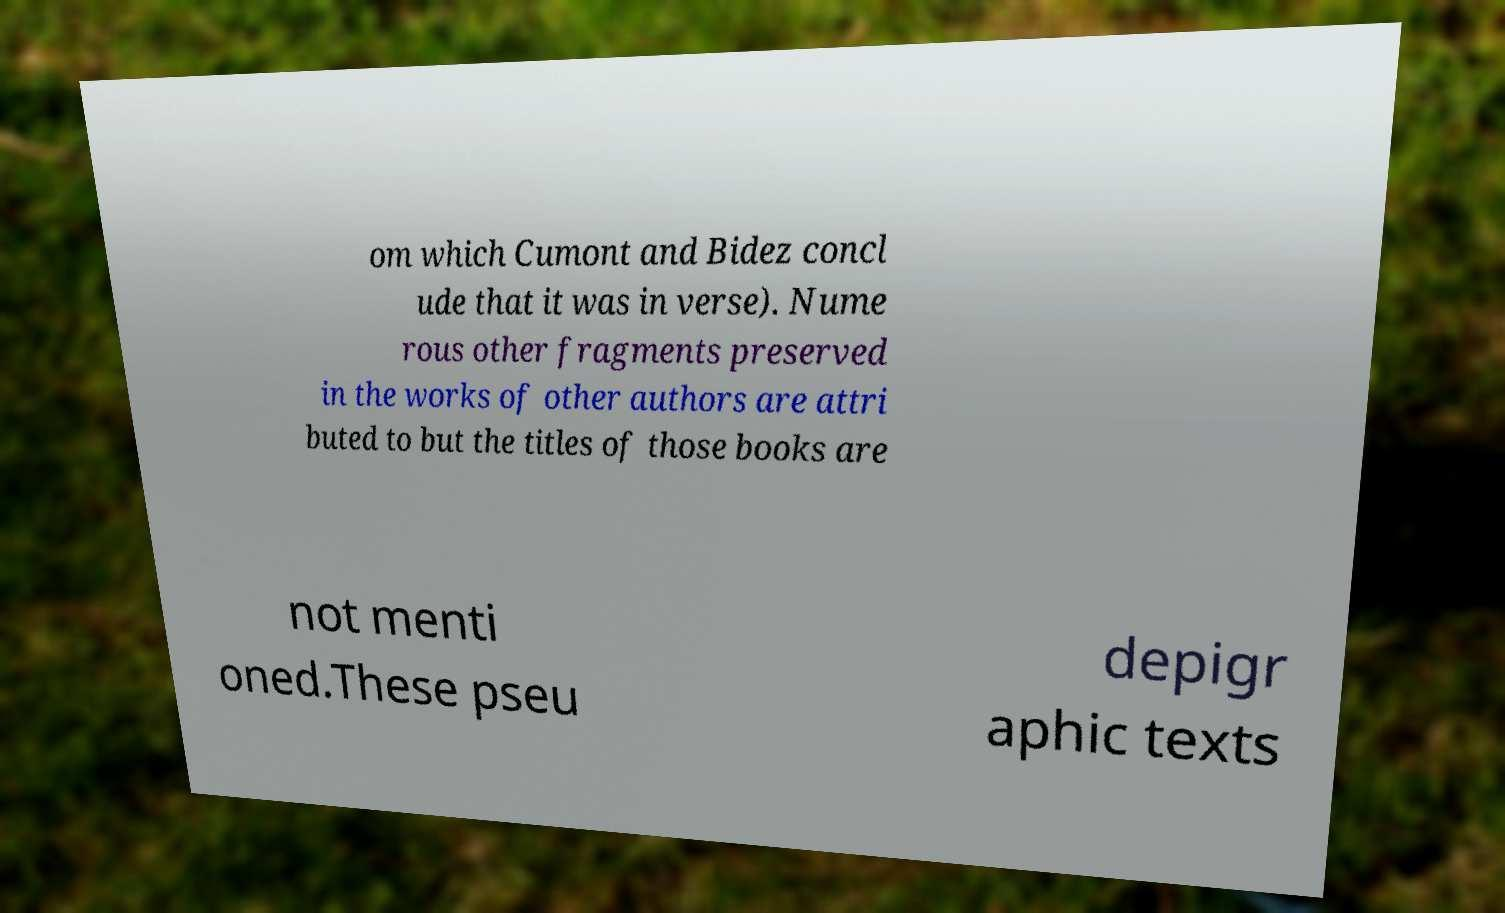I need the written content from this picture converted into text. Can you do that? om which Cumont and Bidez concl ude that it was in verse). Nume rous other fragments preserved in the works of other authors are attri buted to but the titles of those books are not menti oned.These pseu depigr aphic texts 